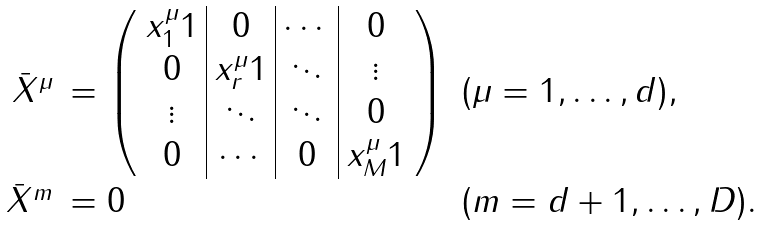<formula> <loc_0><loc_0><loc_500><loc_500>\begin{array} { r l l } \bar { X } ^ { \mu } & = \left ( \begin{array} { c | c | c | c } \strut x _ { 1 } ^ { \mu } { 1 } & { 0 } & \cdots & { 0 } \\ \strut { 0 } & x _ { r } ^ { \mu } { 1 } & \ddots & \vdots \\ \strut \vdots & \ddots & \ddots & { 0 } \\ \strut { 0 } & \cdots & { 0 } & x _ { M } ^ { \mu } { 1 } \end{array} \right ) & ( \mu = 1 , \dots , d ) , \\ \bar { X } ^ { m } & = 0 & ( m = d + 1 , \dots , D ) . \end{array}</formula> 